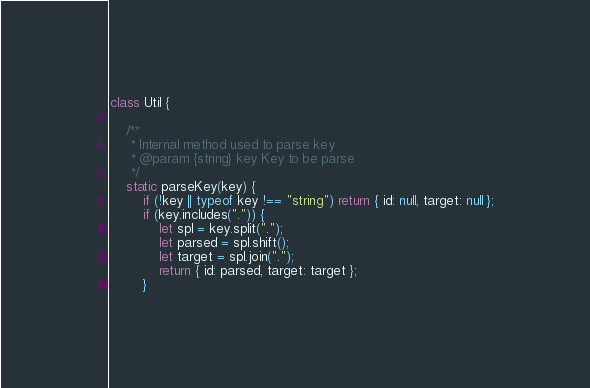<code> <loc_0><loc_0><loc_500><loc_500><_JavaScript_>class Util {

    /**
     * Internal method used to parse key
     * @param {string} key Key to be parse
     */
    static parseKey(key) {
        if (!key || typeof key !== "string") return { id: null, target: null };
        if (key.includes(".")) {
            let spl = key.split(".");
            let parsed = spl.shift();
            let target = spl.join(".");
            return { id: parsed, target: target };
        }</code> 